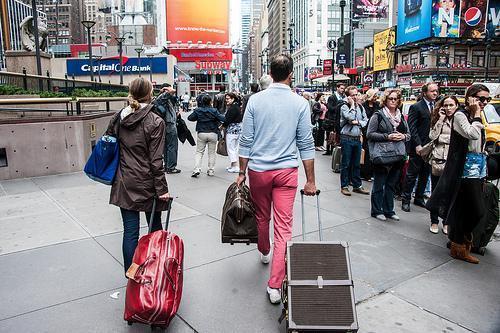How many people are talking on cell phones?
Give a very brief answer. 3. 